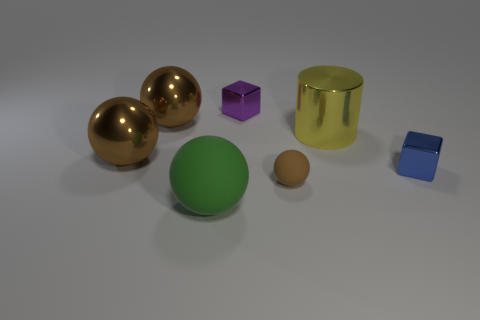Subtract all blue cubes. How many brown balls are left? 3 Add 1 large rubber things. How many objects exist? 8 Subtract all cylinders. How many objects are left? 6 Subtract 0 cyan blocks. How many objects are left? 7 Subtract all tiny brown things. Subtract all small matte spheres. How many objects are left? 5 Add 1 brown balls. How many brown balls are left? 4 Add 2 blue objects. How many blue objects exist? 3 